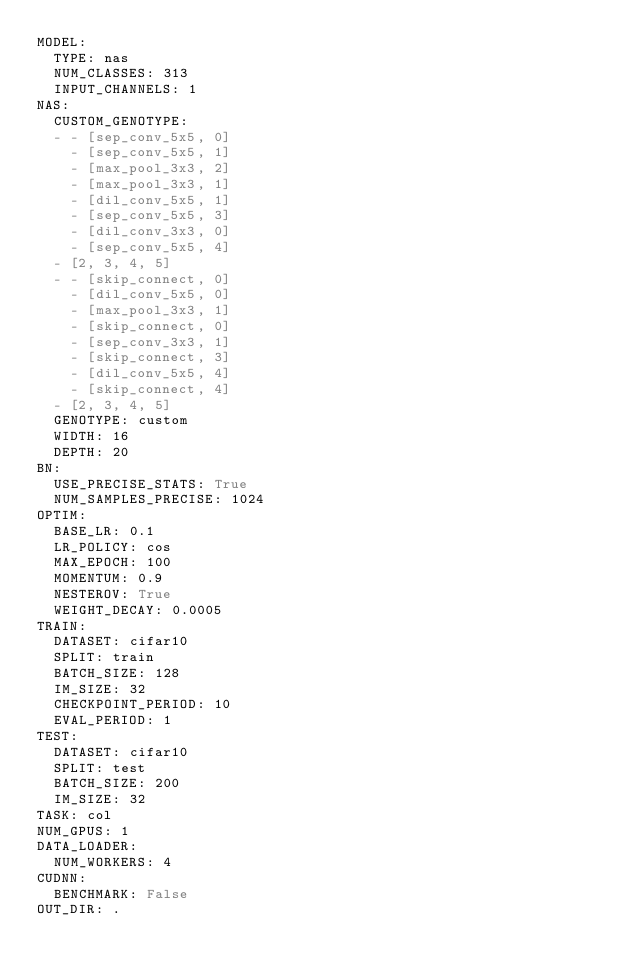Convert code to text. <code><loc_0><loc_0><loc_500><loc_500><_YAML_>MODEL:
  TYPE: nas
  NUM_CLASSES: 313
  INPUT_CHANNELS: 1
NAS:
  CUSTOM_GENOTYPE:
  - - [sep_conv_5x5, 0]
    - [sep_conv_5x5, 1]
    - [max_pool_3x3, 2]
    - [max_pool_3x3, 1]
    - [dil_conv_5x5, 1]
    - [sep_conv_5x5, 3]
    - [dil_conv_3x3, 0]
    - [sep_conv_5x5, 4]
  - [2, 3, 4, 5]
  - - [skip_connect, 0]
    - [dil_conv_5x5, 0]
    - [max_pool_3x3, 1]
    - [skip_connect, 0]
    - [sep_conv_3x3, 1]
    - [skip_connect, 3]
    - [dil_conv_5x5, 4]
    - [skip_connect, 4]
  - [2, 3, 4, 5]
  GENOTYPE: custom
  WIDTH: 16
  DEPTH: 20
BN:
  USE_PRECISE_STATS: True
  NUM_SAMPLES_PRECISE: 1024
OPTIM:
  BASE_LR: 0.1
  LR_POLICY: cos
  MAX_EPOCH: 100
  MOMENTUM: 0.9
  NESTEROV: True
  WEIGHT_DECAY: 0.0005
TRAIN:
  DATASET: cifar10
  SPLIT: train
  BATCH_SIZE: 128
  IM_SIZE: 32
  CHECKPOINT_PERIOD: 10
  EVAL_PERIOD: 1
TEST:
  DATASET: cifar10
  SPLIT: test
  BATCH_SIZE: 200
  IM_SIZE: 32
TASK: col
NUM_GPUS: 1
DATA_LOADER:
  NUM_WORKERS: 4
CUDNN:
  BENCHMARK: False
OUT_DIR: .
</code> 